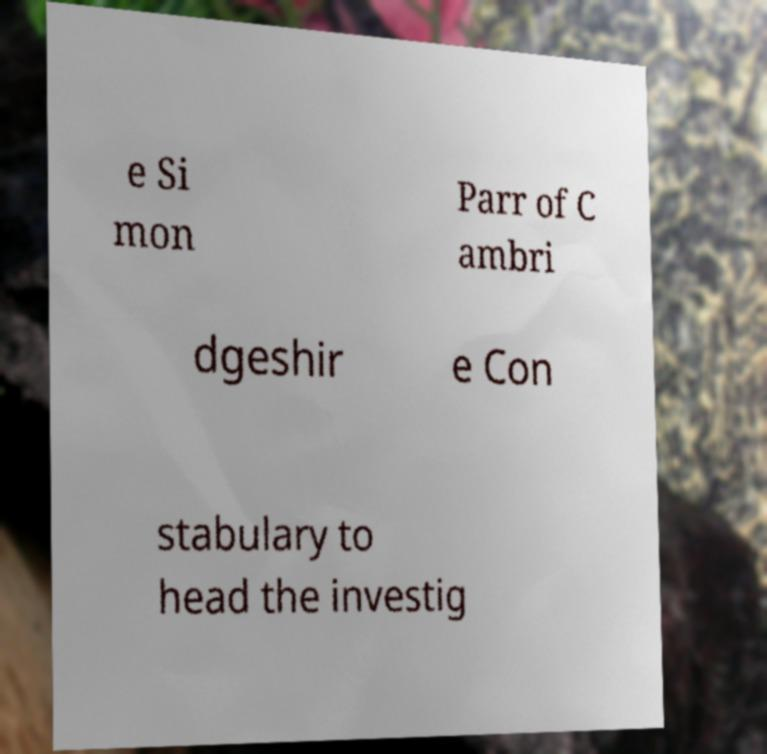I need the written content from this picture converted into text. Can you do that? e Si mon Parr of C ambri dgeshir e Con stabulary to head the investig 